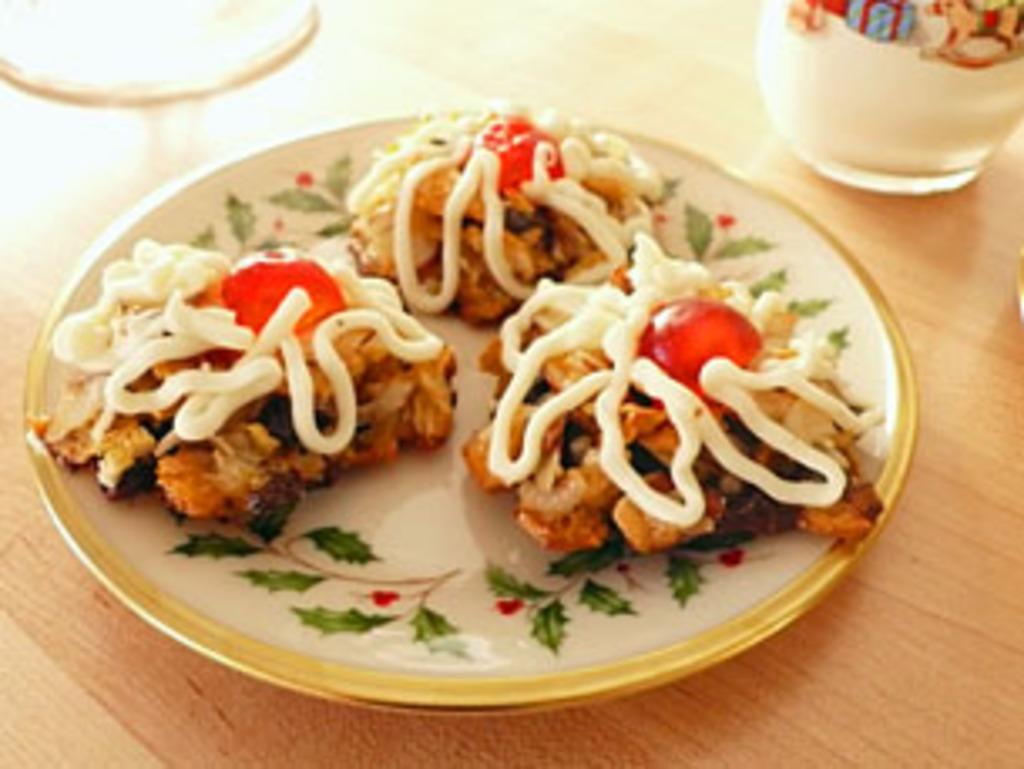Describe this image in one or two sentences. In this picture we can see food in the plate, beside to the plate we can find a glass on the table. 